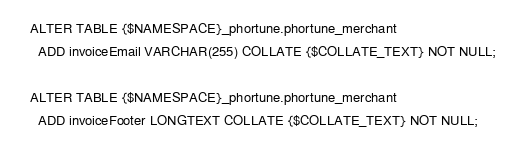Convert code to text. <code><loc_0><loc_0><loc_500><loc_500><_SQL_>ALTER TABLE {$NAMESPACE}_phortune.phortune_merchant
  ADD invoiceEmail VARCHAR(255) COLLATE {$COLLATE_TEXT} NOT NULL;

ALTER TABLE {$NAMESPACE}_phortune.phortune_merchant
  ADD invoiceFooter LONGTEXT COLLATE {$COLLATE_TEXT} NOT NULL;
</code> 